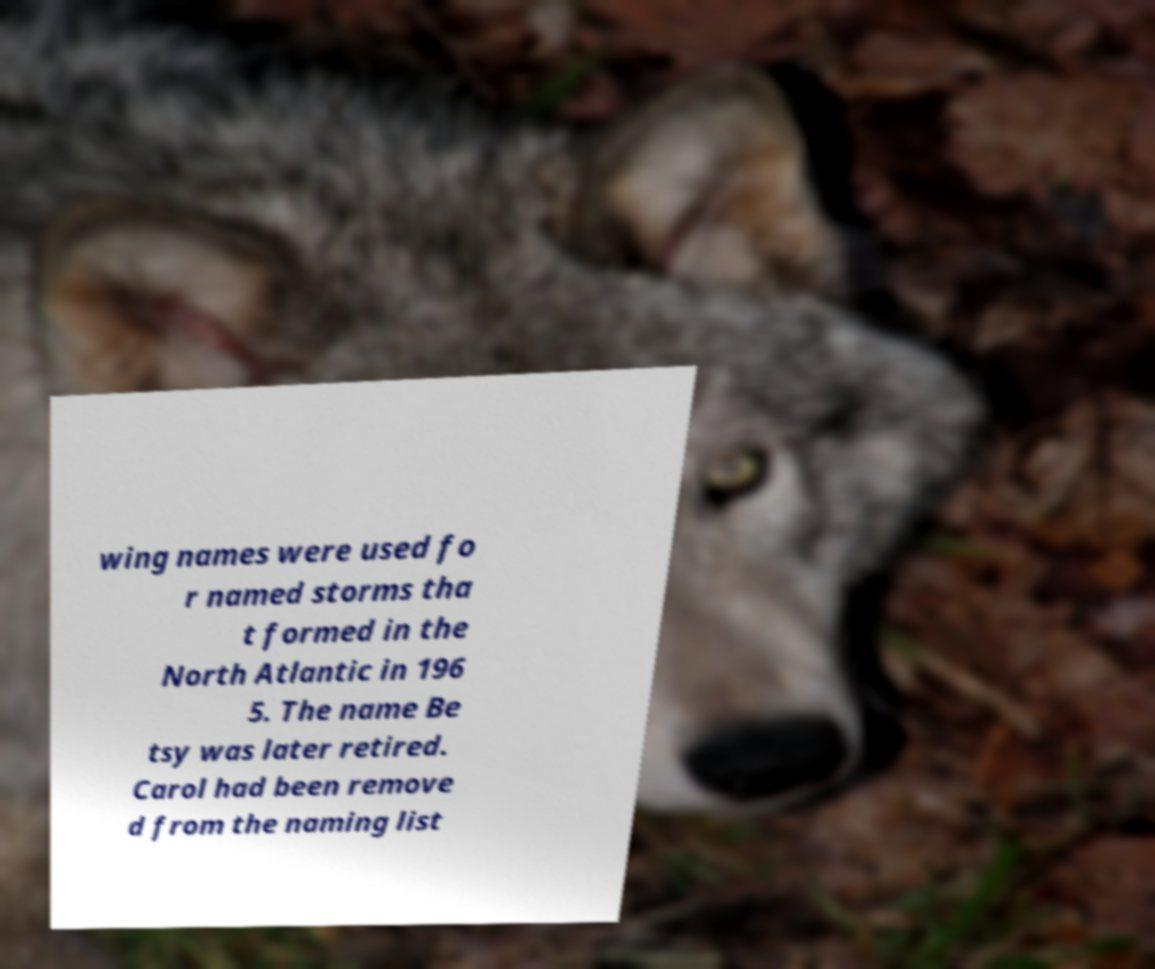Could you extract and type out the text from this image? wing names were used fo r named storms tha t formed in the North Atlantic in 196 5. The name Be tsy was later retired. Carol had been remove d from the naming list 